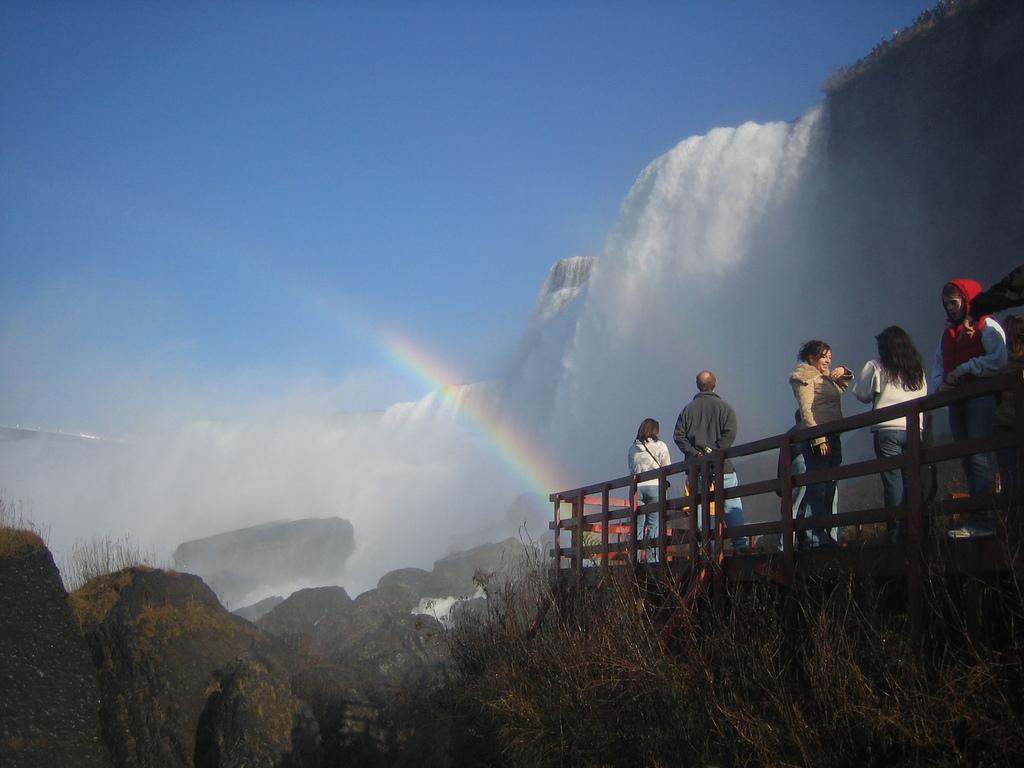Please provide a concise description of this image. On the right side of the image we can see few people, they are all standing, beside them we can see few plants and rocks, in front of them we can find waterfall. 